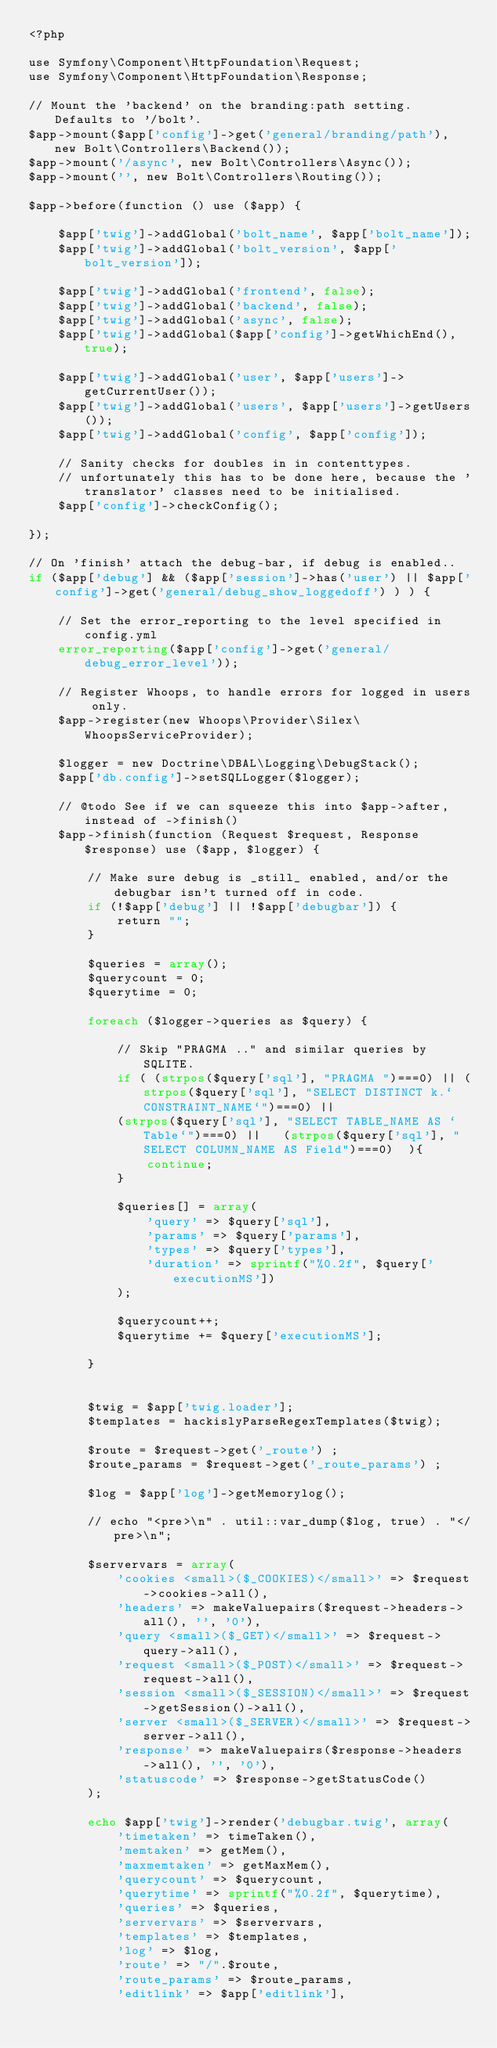Convert code to text. <code><loc_0><loc_0><loc_500><loc_500><_PHP_><?php

use Symfony\Component\HttpFoundation\Request;
use Symfony\Component\HttpFoundation\Response;

// Mount the 'backend' on the branding:path setting. Defaults to '/bolt'.
$app->mount($app['config']->get('general/branding/path'), new Bolt\Controllers\Backend());
$app->mount('/async', new Bolt\Controllers\Async());
$app->mount('', new Bolt\Controllers\Routing());

$app->before(function () use ($app) {

    $app['twig']->addGlobal('bolt_name', $app['bolt_name']);
    $app['twig']->addGlobal('bolt_version', $app['bolt_version']);

    $app['twig']->addGlobal('frontend', false);
    $app['twig']->addGlobal('backend', false);
    $app['twig']->addGlobal('async', false);
    $app['twig']->addGlobal($app['config']->getWhichEnd(), true);

    $app['twig']->addGlobal('user', $app['users']->getCurrentUser());
    $app['twig']->addGlobal('users', $app['users']->getUsers());
    $app['twig']->addGlobal('config', $app['config']);

    // Sanity checks for doubles in in contenttypes.
    // unfortunately this has to be done here, because the 'translator' classes need to be initialised.
    $app['config']->checkConfig();

});

// On 'finish' attach the debug-bar, if debug is enabled..
if ($app['debug'] && ($app['session']->has('user') || $app['config']->get('general/debug_show_loggedoff') ) ) {

    // Set the error_reporting to the level specified in config.yml
    error_reporting($app['config']->get('general/debug_error_level'));

    // Register Whoops, to handle errors for logged in users only.
    $app->register(new Whoops\Provider\Silex\WhoopsServiceProvider);

    $logger = new Doctrine\DBAL\Logging\DebugStack();
    $app['db.config']->setSQLLogger($logger);

    // @todo See if we can squeeze this into $app->after, instead of ->finish()
    $app->finish(function (Request $request, Response $response) use ($app, $logger) {

        // Make sure debug is _still_ enabled, and/or the debugbar isn't turned off in code.
        if (!$app['debug'] || !$app['debugbar']) {
            return "";
        }

        $queries = array();
        $querycount = 0;
        $querytime = 0;

        foreach ($logger->queries as $query) {

            // Skip "PRAGMA .." and similar queries by SQLITE.
            if ( (strpos($query['sql'], "PRAGMA ")===0) || (strpos($query['sql'], "SELECT DISTINCT k.`CONSTRAINT_NAME`")===0) ||
            (strpos($query['sql'], "SELECT TABLE_NAME AS `Table`")===0) ||   (strpos($query['sql'], "SELECT COLUMN_NAME AS Field")===0)  ){
                continue;
            }

            $queries[] = array(
                'query' => $query['sql'],
                'params' => $query['params'],
                'types' => $query['types'],
                'duration' => sprintf("%0.2f", $query['executionMS'])
            );

            $querycount++;
            $querytime += $query['executionMS'];

        }


        $twig = $app['twig.loader'];
        $templates = hackislyParseRegexTemplates($twig);

        $route = $request->get('_route') ;
        $route_params = $request->get('_route_params') ;

        $log = $app['log']->getMemorylog();

        // echo "<pre>\n" . util::var_dump($log, true) . "</pre>\n";

        $servervars = array(
            'cookies <small>($_COOKIES)</small>' => $request->cookies->all(),
            'headers' => makeValuepairs($request->headers->all(), '', '0'),
            'query <small>($_GET)</small>' => $request->query->all(),
            'request <small>($_POST)</small>' => $request->request->all(),
            'session <small>($_SESSION)</small>' => $request->getSession()->all(),
            'server <small>($_SERVER)</small>' => $request->server->all(),
            'response' => makeValuepairs($response->headers->all(), '', '0'),
            'statuscode' => $response->getStatusCode()
        );

        echo $app['twig']->render('debugbar.twig', array(
            'timetaken' => timeTaken(),
            'memtaken' => getMem(),
            'maxmemtaken' => getMaxMem(),
            'querycount' => $querycount,
            'querytime' => sprintf("%0.2f", $querytime),
            'queries' => $queries,
            'servervars' => $servervars,
            'templates' => $templates,
            'log' => $log,
            'route' => "/".$route,
            'route_params' => $route_params,
            'editlink' => $app['editlink'],</code> 